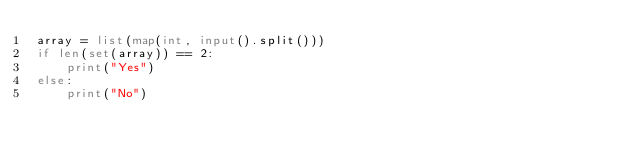Convert code to text. <code><loc_0><loc_0><loc_500><loc_500><_Python_>array = list(map(int, input().split()))
if len(set(array)) == 2:
    print("Yes")
else:
    print("No")</code> 